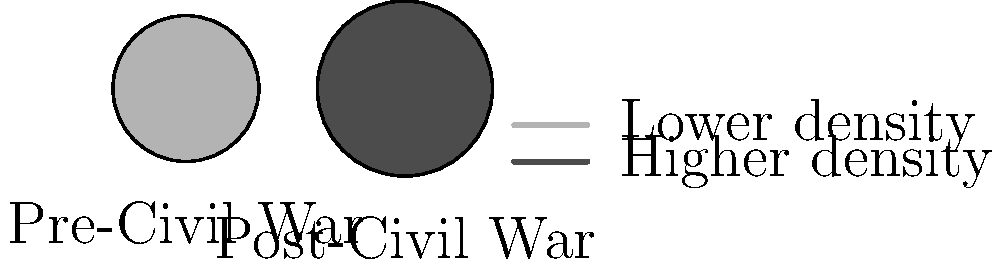Based on the shaded maps representing population density changes in a major city before and after the Civil War, what conclusion can be drawn about the city's demographic shift? To analyze the population density changes:

1. Observe the Pre-Civil War map:
   - Smaller circle size
   - Lighter shade (gray(0.7))

2. Observe the Post-Civil War map:
   - Larger circle size
   - Darker shade (gray(0.3))

3. Interpret the legend:
   - Lighter shade represents lower density
   - Darker shade represents higher density

4. Compare the two maps:
   - The Post-Civil War map has a larger area (circle size increased)
   - The Post-Civil War map has a darker shade

5. Draw conclusions:
   - The city experienced significant population growth
   - The population density increased substantially

This demographic shift indicates urbanization and potential industrialization following the Civil War, which would be a crucial aspect of social dynamics during this period.
Answer: Significant urban population growth and density increase 